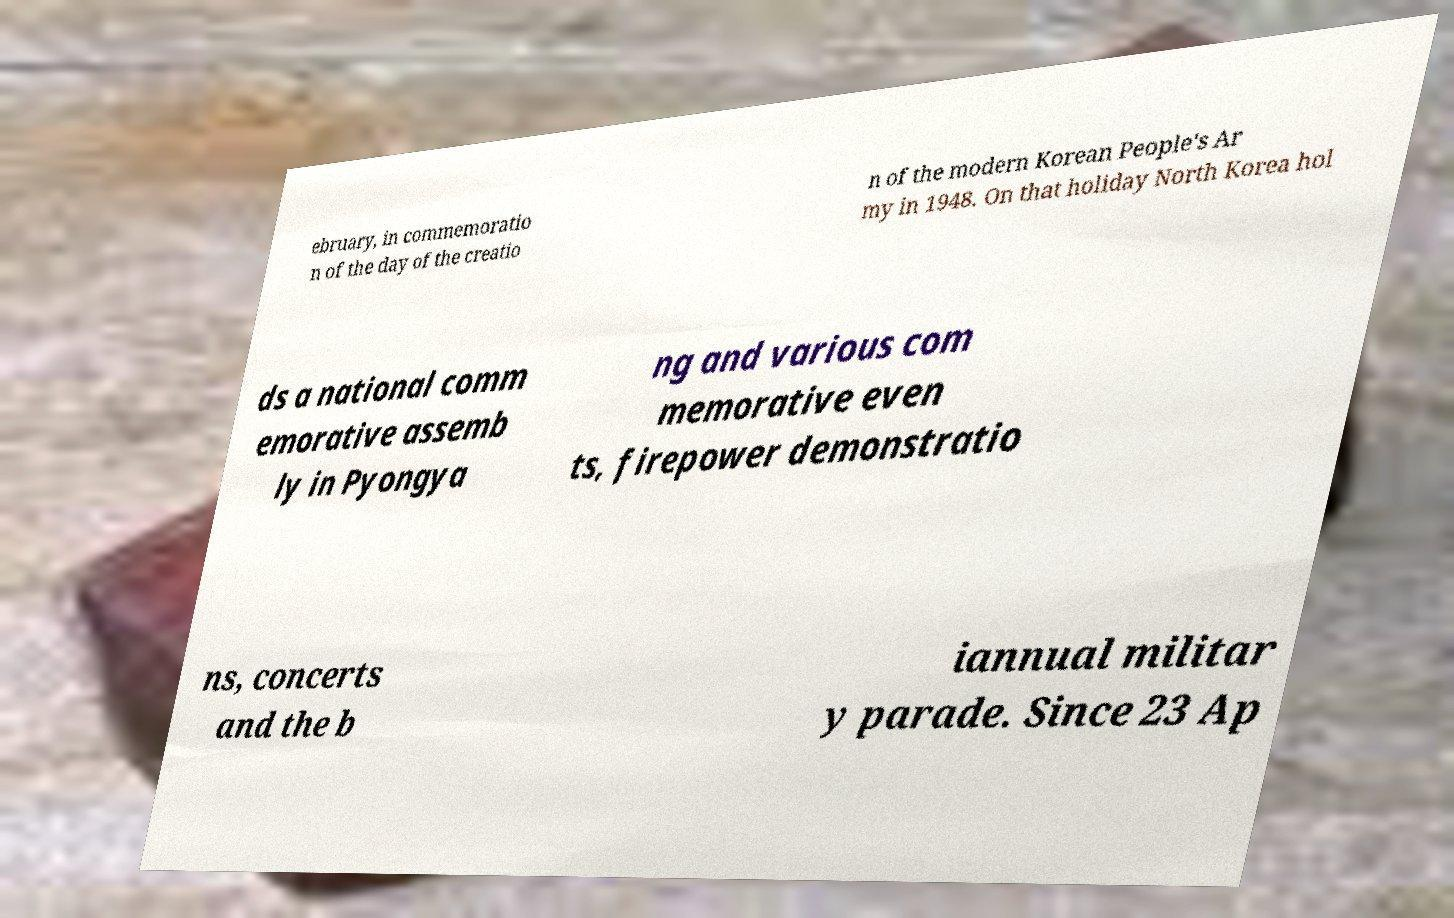Can you read and provide the text displayed in the image?This photo seems to have some interesting text. Can you extract and type it out for me? ebruary, in commemoratio n of the day of the creatio n of the modern Korean People's Ar my in 1948. On that holiday North Korea hol ds a national comm emorative assemb ly in Pyongya ng and various com memorative even ts, firepower demonstratio ns, concerts and the b iannual militar y parade. Since 23 Ap 